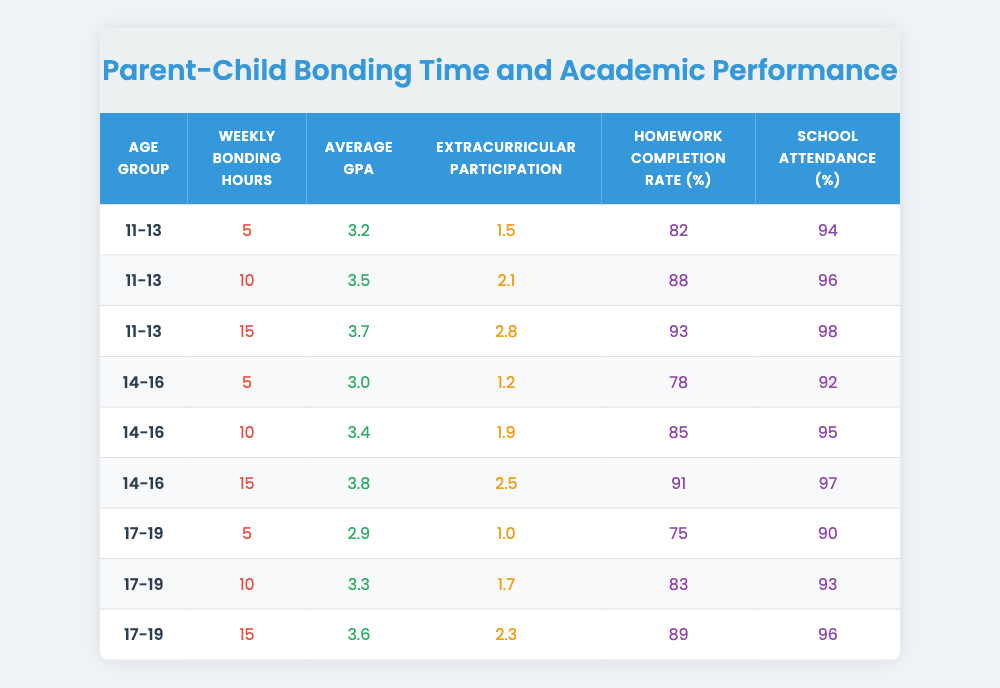What is the average GPA for the age group 11-13? The average GPA for the age group 11-13 from the table is calculated by taking the GPAs for each of the three entries in this group (3.2, 3.5, and 3.7), summing them (3.2 + 3.5 + 3.7 = 10.4), and dividing by the number of entries (3). Thus, 10.4 ÷ 3 = 3.47.
Answer: 3.47 How many weekly bonding hours are associated with the highest Average GPA in the 14-16 age group? Among the entries for the 14-16 age group, the highest Average GPA is 3.8, which corresponds to 15 weekly bonding hours.
Answer: 15 What is the Homework Completion Rate (%) for the age group 17-19 with the lowest bonding hours? The entry with the lowest bonding hours for the age group 17-19 shows 5 weekly bonding hours, which corresponds to a Homework Completion Rate of 75%.
Answer: 75% Is there an increase in Average GPA when moving from 10 to 15 weekly bonding hours in the age group 11-13? Yes, in the age group 11-13, moving from 10 weekly bonding hours (GPA of 3.5) to 15 weekly bonding hours (GPA of 3.7) shows an increase of 0.2 in Average GPA.
Answer: Yes What is the trend in School Attendance (%) as Weekly Bonding Hours increase across all age groups? Observing all age groups, as Weekly Bonding Hours increase, School Attendance (%) tends to increase as well: for example, 5 hours corresponds to lower attendance percentages while 15 hours corresponds to the highest attendance percentages across the groups. This indicates a positive trend.
Answer: Positive trend Which age group has the highest Extracurricular Participation? The age group 14-16 has the highest Extracurricular Participation average of 2.5, associated with 15 weekly bonding hours, which is higher than any participation in the other age groups.
Answer: 14-16 Calculate the average Homework Completion Rate (%) for all age groups combined. To find this, add the Homework Completion Rates from all entries (82 + 88 + 93 + 78 + 85 + 91 + 75 + 83 + 89 = 789), then divide by the number of entries (9), yielding 789 ÷ 9 = 87.67 roughly.
Answer: 87.67 Is there a consistent increase in Average GPA across all age groups with increasing bonding hours? While the Average GPA increases with bonding hours in each individual age group, the increase is consistent in the groups 11-13 and 14-16. However, from 17-19, there's a drop between 5 and 10 hours, showing inconsistency at that point.
Answer: No 